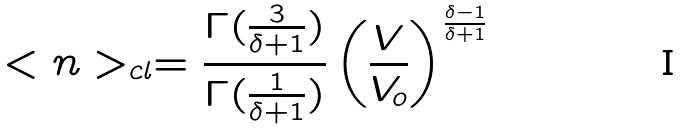Convert formula to latex. <formula><loc_0><loc_0><loc_500><loc_500>< n > _ { c l } = \frac { \Gamma ( \frac { 3 } { \delta + 1 } ) } { \Gamma ( \frac { 1 } { \delta + 1 } ) } \left ( \frac { V } { V _ { o } } \right ) ^ { \frac { \delta - 1 } { \delta + 1 } }</formula> 